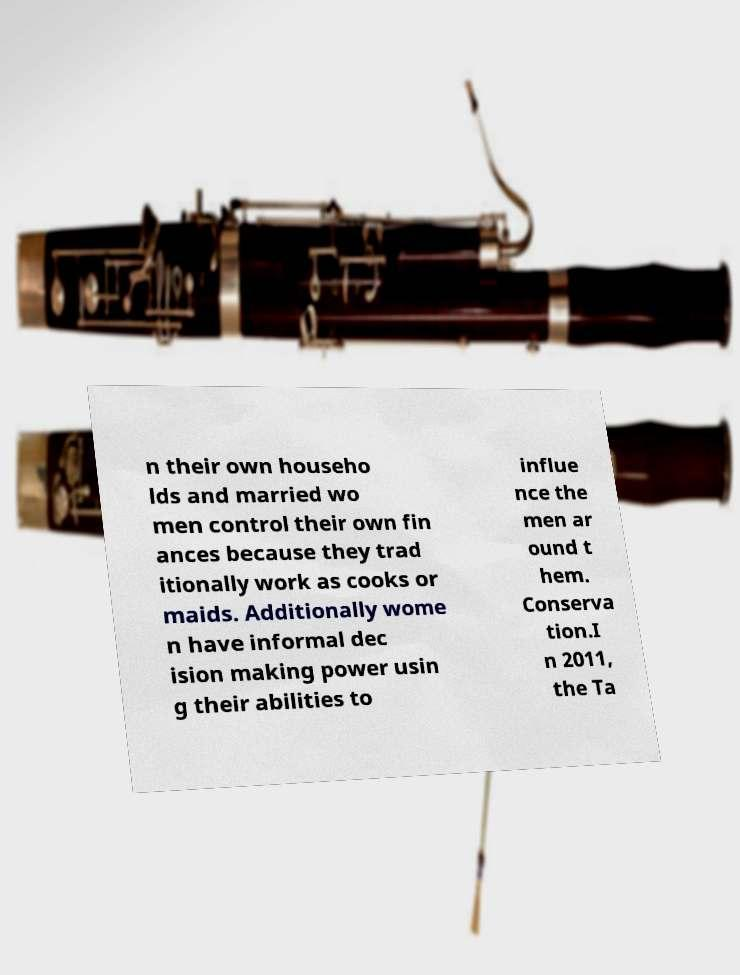What messages or text are displayed in this image? I need them in a readable, typed format. n their own househo lds and married wo men control their own fin ances because they trad itionally work as cooks or maids. Additionally wome n have informal dec ision making power usin g their abilities to influe nce the men ar ound t hem. Conserva tion.I n 2011, the Ta 